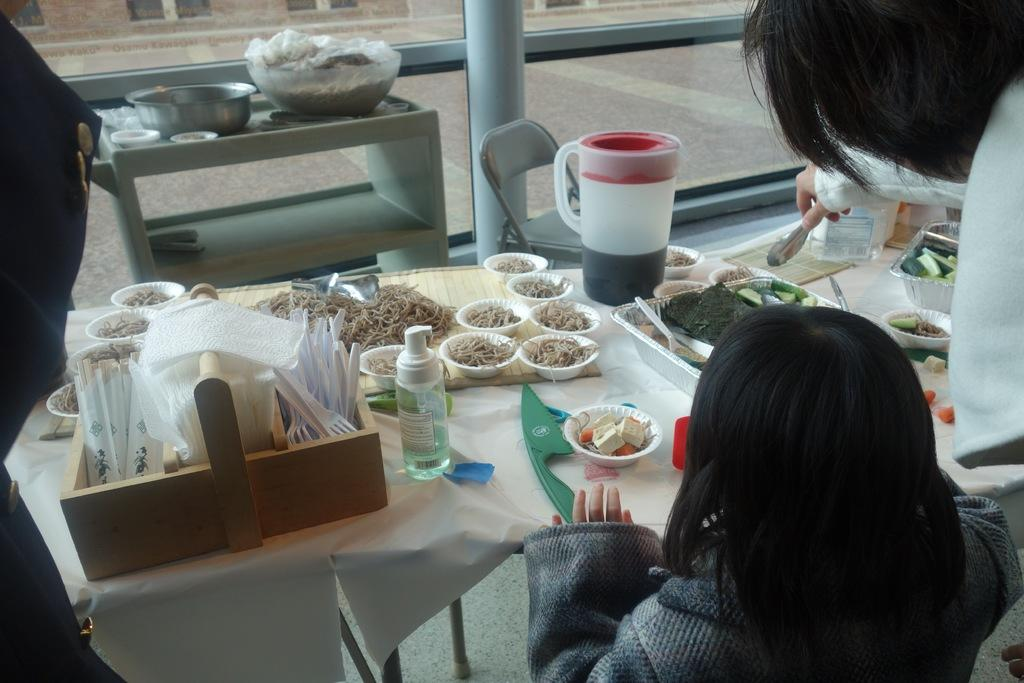What is the girl doing in the image? The girl is sitting at a dining table. What can be seen on the table in the image? Food is served on the table, and there is a tray of tissues. What is the woman doing in the image? The woman is serving food to the girl. How many people are present in the image? There are two people present, the girl and the woman. What type of pest can be seen crawling on the girl's tongue in the image? There is no pest present on the girl's tongue in the image. What statement is the girl making in the image? The image does not show the girl making any statement. 